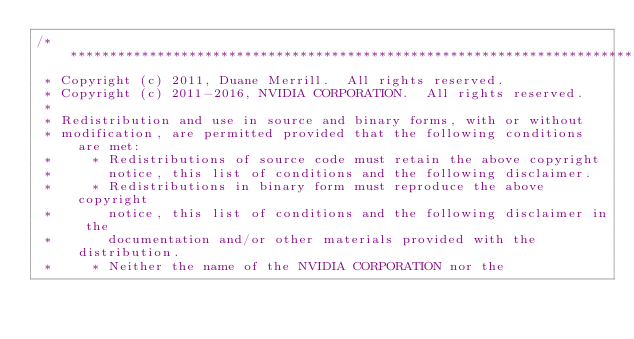<code> <loc_0><loc_0><loc_500><loc_500><_Cuda_>/******************************************************************************
 * Copyright (c) 2011, Duane Merrill.  All rights reserved.
 * Copyright (c) 2011-2016, NVIDIA CORPORATION.  All rights reserved.
 * 
 * Redistribution and use in source and binary forms, with or without
 * modification, are permitted provided that the following conditions are met:
 *     * Redistributions of source code must retain the above copyright
 *       notice, this list of conditions and the following disclaimer.
 *     * Redistributions in binary form must reproduce the above copyright
 *       notice, this list of conditions and the following disclaimer in the
 *       documentation and/or other materials provided with the distribution.
 *     * Neither the name of the NVIDIA CORPORATION nor the</code> 